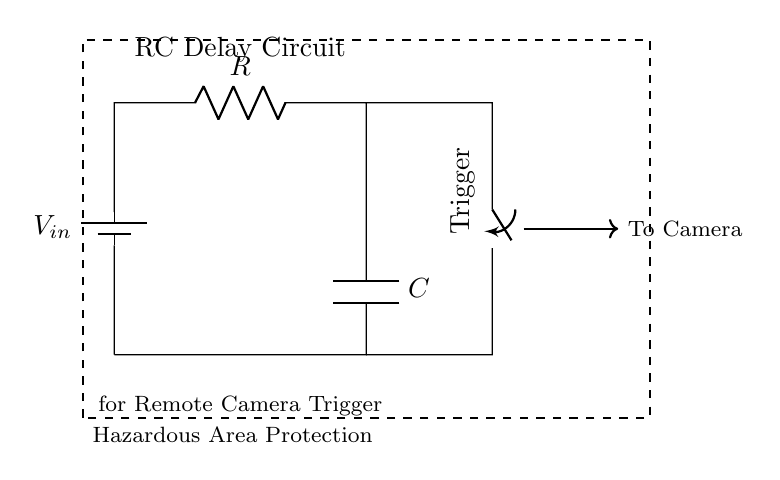What is the type of the main components in this circuit? The main components in this circuit are a resistor and a capacitor, which are used to create an RC delay.
Answer: resistor and capacitor What is the role of the switch in this circuit? The switch in this circuit acts as a trigger, allowing the user to control when the circuit activates the camera. When closed, it connects the capacitor and resistor to allow the delay to take place.
Answer: control What is the direction of current flow from the battery? Current flows from the positive terminal of the battery through the resistor, then through the capacitor, and returns to the negative terminal. The arrow direction shows this path clearly.
Answer: clockwise What happens when the switch is closed? When the switch is closed, the capacitor starts charging through the resistor, creating a delay before the camera is triggered. The time it takes for the camera to activate depends on the values of R and C.
Answer: triggers camera What is the effect of increasing the resistance value in this circuit? Increasing the resistance value will increase the time constant (RC time), resulting in a longer delay before the camera is triggered. This shift occurs because a higher resistor restricts the current flow, causing the capacitor to take longer to charge.
Answer: longer delay Which area does this circuit aim to protect? The circuit designates a hazardous area for protection, ensuring that remote camera operations do not expose operators to risks near nuclear facilities. This is indicated by the "Hazardous Area Protection" label surrounding the components.
Answer: hazardous area 